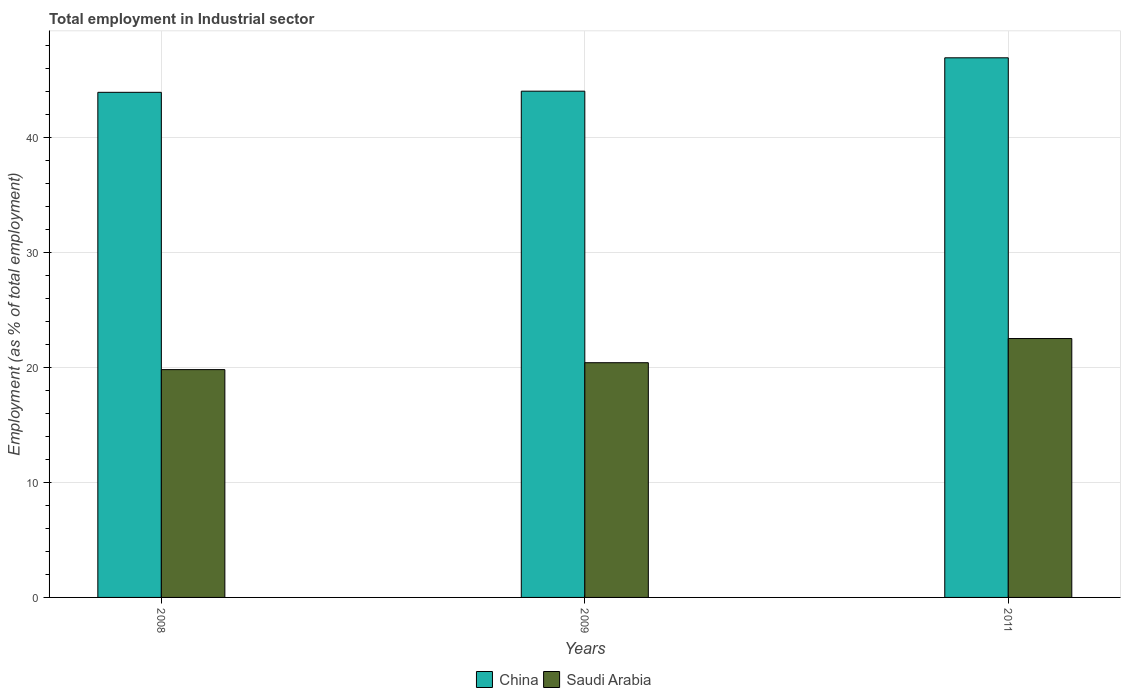How many different coloured bars are there?
Provide a short and direct response. 2. How many bars are there on the 2nd tick from the left?
Ensure brevity in your answer.  2. How many bars are there on the 1st tick from the right?
Keep it short and to the point. 2. What is the label of the 3rd group of bars from the left?
Provide a short and direct response. 2011. In how many cases, is the number of bars for a given year not equal to the number of legend labels?
Your answer should be very brief. 0. What is the employment in industrial sector in China in 2008?
Make the answer very short. 43.9. Across all years, what is the maximum employment in industrial sector in Saudi Arabia?
Keep it short and to the point. 22.5. Across all years, what is the minimum employment in industrial sector in China?
Provide a succinct answer. 43.9. What is the total employment in industrial sector in Saudi Arabia in the graph?
Give a very brief answer. 62.7. What is the difference between the employment in industrial sector in China in 2008 and that in 2009?
Give a very brief answer. -0.1. What is the difference between the employment in industrial sector in China in 2008 and the employment in industrial sector in Saudi Arabia in 2009?
Your answer should be very brief. 23.5. What is the average employment in industrial sector in China per year?
Provide a succinct answer. 44.93. In the year 2008, what is the difference between the employment in industrial sector in Saudi Arabia and employment in industrial sector in China?
Keep it short and to the point. -24.1. What is the ratio of the employment in industrial sector in Saudi Arabia in 2009 to that in 2011?
Offer a very short reply. 0.91. Is the employment in industrial sector in Saudi Arabia in 2008 less than that in 2011?
Provide a succinct answer. Yes. What is the difference between the highest and the second highest employment in industrial sector in China?
Make the answer very short. 2.9. What is the difference between the highest and the lowest employment in industrial sector in Saudi Arabia?
Your response must be concise. 2.7. What does the 1st bar from the right in 2011 represents?
Provide a succinct answer. Saudi Arabia. How many bars are there?
Ensure brevity in your answer.  6. Are all the bars in the graph horizontal?
Provide a short and direct response. No. How many years are there in the graph?
Give a very brief answer. 3. What is the difference between two consecutive major ticks on the Y-axis?
Keep it short and to the point. 10. Are the values on the major ticks of Y-axis written in scientific E-notation?
Your answer should be compact. No. Does the graph contain grids?
Offer a very short reply. Yes. Where does the legend appear in the graph?
Offer a very short reply. Bottom center. How many legend labels are there?
Ensure brevity in your answer.  2. What is the title of the graph?
Provide a short and direct response. Total employment in Industrial sector. Does "Cambodia" appear as one of the legend labels in the graph?
Your answer should be very brief. No. What is the label or title of the Y-axis?
Give a very brief answer. Employment (as % of total employment). What is the Employment (as % of total employment) in China in 2008?
Your response must be concise. 43.9. What is the Employment (as % of total employment) in Saudi Arabia in 2008?
Keep it short and to the point. 19.8. What is the Employment (as % of total employment) of China in 2009?
Offer a very short reply. 44. What is the Employment (as % of total employment) in Saudi Arabia in 2009?
Offer a terse response. 20.4. What is the Employment (as % of total employment) of China in 2011?
Offer a terse response. 46.9. Across all years, what is the maximum Employment (as % of total employment) in China?
Your response must be concise. 46.9. Across all years, what is the minimum Employment (as % of total employment) in China?
Ensure brevity in your answer.  43.9. Across all years, what is the minimum Employment (as % of total employment) in Saudi Arabia?
Make the answer very short. 19.8. What is the total Employment (as % of total employment) in China in the graph?
Your response must be concise. 134.8. What is the total Employment (as % of total employment) in Saudi Arabia in the graph?
Make the answer very short. 62.7. What is the difference between the Employment (as % of total employment) of China in 2009 and that in 2011?
Give a very brief answer. -2.9. What is the difference between the Employment (as % of total employment) in China in 2008 and the Employment (as % of total employment) in Saudi Arabia in 2009?
Give a very brief answer. 23.5. What is the difference between the Employment (as % of total employment) of China in 2008 and the Employment (as % of total employment) of Saudi Arabia in 2011?
Your response must be concise. 21.4. What is the difference between the Employment (as % of total employment) in China in 2009 and the Employment (as % of total employment) in Saudi Arabia in 2011?
Your answer should be compact. 21.5. What is the average Employment (as % of total employment) in China per year?
Give a very brief answer. 44.93. What is the average Employment (as % of total employment) in Saudi Arabia per year?
Provide a succinct answer. 20.9. In the year 2008, what is the difference between the Employment (as % of total employment) in China and Employment (as % of total employment) in Saudi Arabia?
Make the answer very short. 24.1. In the year 2009, what is the difference between the Employment (as % of total employment) in China and Employment (as % of total employment) in Saudi Arabia?
Ensure brevity in your answer.  23.6. In the year 2011, what is the difference between the Employment (as % of total employment) in China and Employment (as % of total employment) in Saudi Arabia?
Keep it short and to the point. 24.4. What is the ratio of the Employment (as % of total employment) of Saudi Arabia in 2008 to that in 2009?
Keep it short and to the point. 0.97. What is the ratio of the Employment (as % of total employment) of China in 2008 to that in 2011?
Provide a short and direct response. 0.94. What is the ratio of the Employment (as % of total employment) in Saudi Arabia in 2008 to that in 2011?
Your answer should be very brief. 0.88. What is the ratio of the Employment (as % of total employment) of China in 2009 to that in 2011?
Offer a very short reply. 0.94. What is the ratio of the Employment (as % of total employment) of Saudi Arabia in 2009 to that in 2011?
Your answer should be very brief. 0.91. What is the difference between the highest and the second highest Employment (as % of total employment) in Saudi Arabia?
Provide a succinct answer. 2.1. What is the difference between the highest and the lowest Employment (as % of total employment) in China?
Give a very brief answer. 3. 